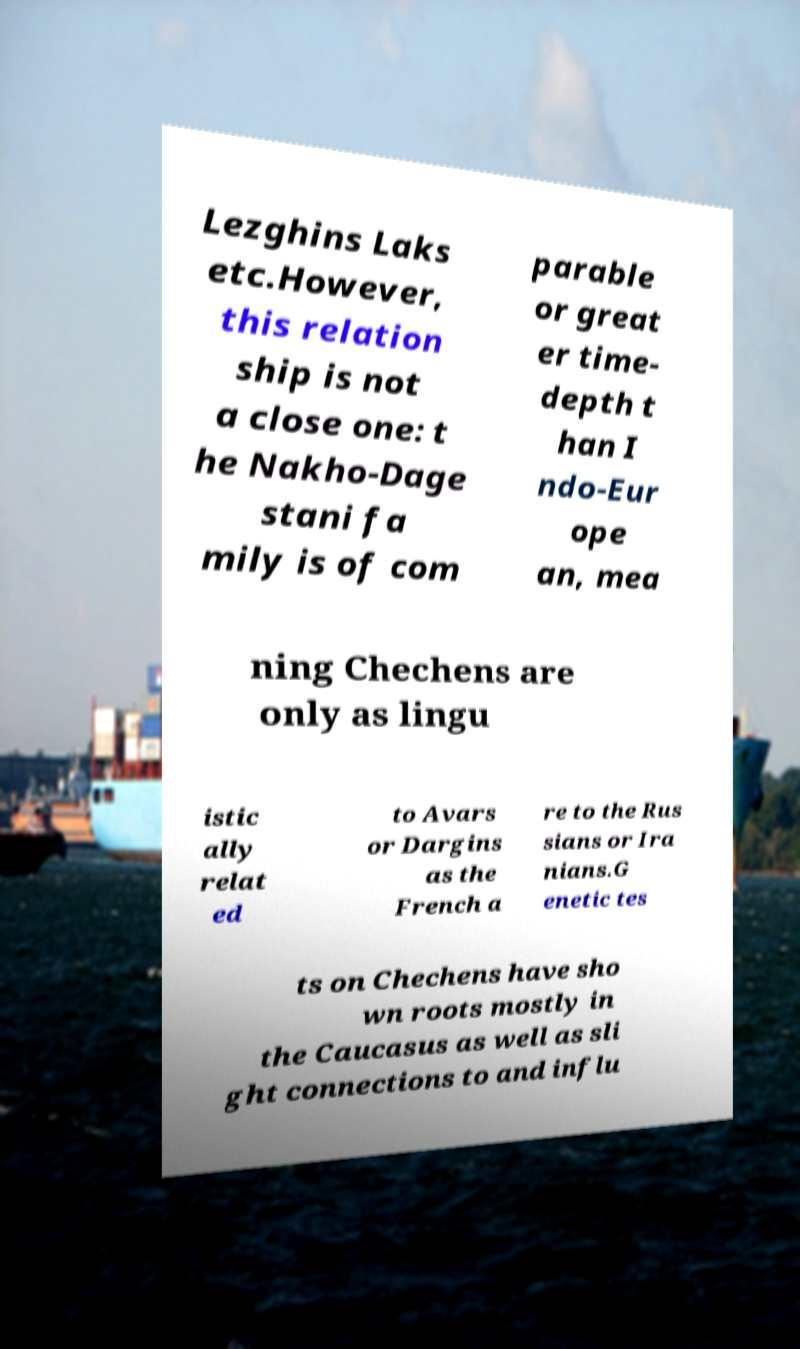Can you read and provide the text displayed in the image?This photo seems to have some interesting text. Can you extract and type it out for me? Lezghins Laks etc.However, this relation ship is not a close one: t he Nakho-Dage stani fa mily is of com parable or great er time- depth t han I ndo-Eur ope an, mea ning Chechens are only as lingu istic ally relat ed to Avars or Dargins as the French a re to the Rus sians or Ira nians.G enetic tes ts on Chechens have sho wn roots mostly in the Caucasus as well as sli ght connections to and influ 